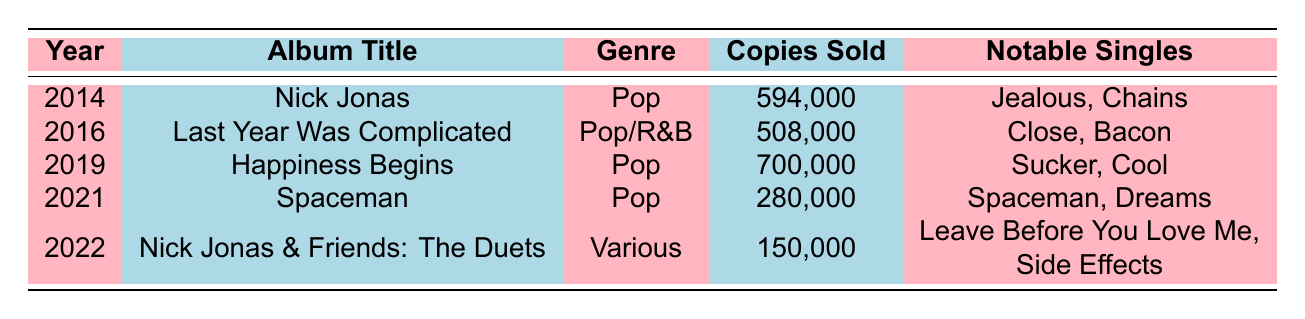What year did Nick Jonas release his most successful album in terms of sales? Looking at the "Copies Sold" column, the highest value is 700,000, which corresponds to the album "Happiness Begins" released in 2019.
Answer: 2019 Which album sold the least number of copies? The album "Nick Jonas & Friends: The Duets" from 2022 has the lowest sales figure of 150,000 copies.
Answer: Nick Jonas & Friends: The Duets How many copies did Nick Jonas sell in total across all his albums? Summing the copies sold: 594,000 + 508,000 + 700,000 + 280,000 + 150,000 = 2,232,000.
Answer: 2,232,000 Did Nick Jonas release any R&B albums? Yes, "Last Year Was Complicated" from 2016 is categorized under Pop/R&B.
Answer: Yes What is the average number of copies sold per album? The total sales are 2,232,000 and there are 5 albums, so the average is 2,232,000 / 5 = 446,400.
Answer: 446,400 Which notable single is associated with the album "Spaceman"? The notable singles for "Spaceman" are "Spaceman" and "Dreams."
Answer: Spaceman, Dreams How many albums released in Pop genre have sold over 500,000 copies? "Nick Jonas" (594,000) and "Happiness Begins" (700,000) are the only two Pop albums with sales over 500,000.
Answer: 2 In which year did Nick Jonas experience a decline in sales compared to the previous album? From 2019 ("Happiness Begins" with 700,000) to 2021 ("Spaceman" with 280,000), there was a decline in sales.
Answer: 2021 What is the combined sales figure for Nick Jonas' albums released from 2016 to 2022? Adding the sales from "Last Year Was Complicated" (508,000), "Happiness Begins" (700,000), "Spaceman" (280,000), and "Nick Jonas & Friends: The Duets" (150,000) gives: 508,000 + 700,000 + 280,000 + 150,000 = 1,638,000.
Answer: 1,638,000 How many notable singles are associated with the album "Happiness Begins"? The album "Happiness Begins" has two notable singles: "Sucker" and "Cool."
Answer: 2 